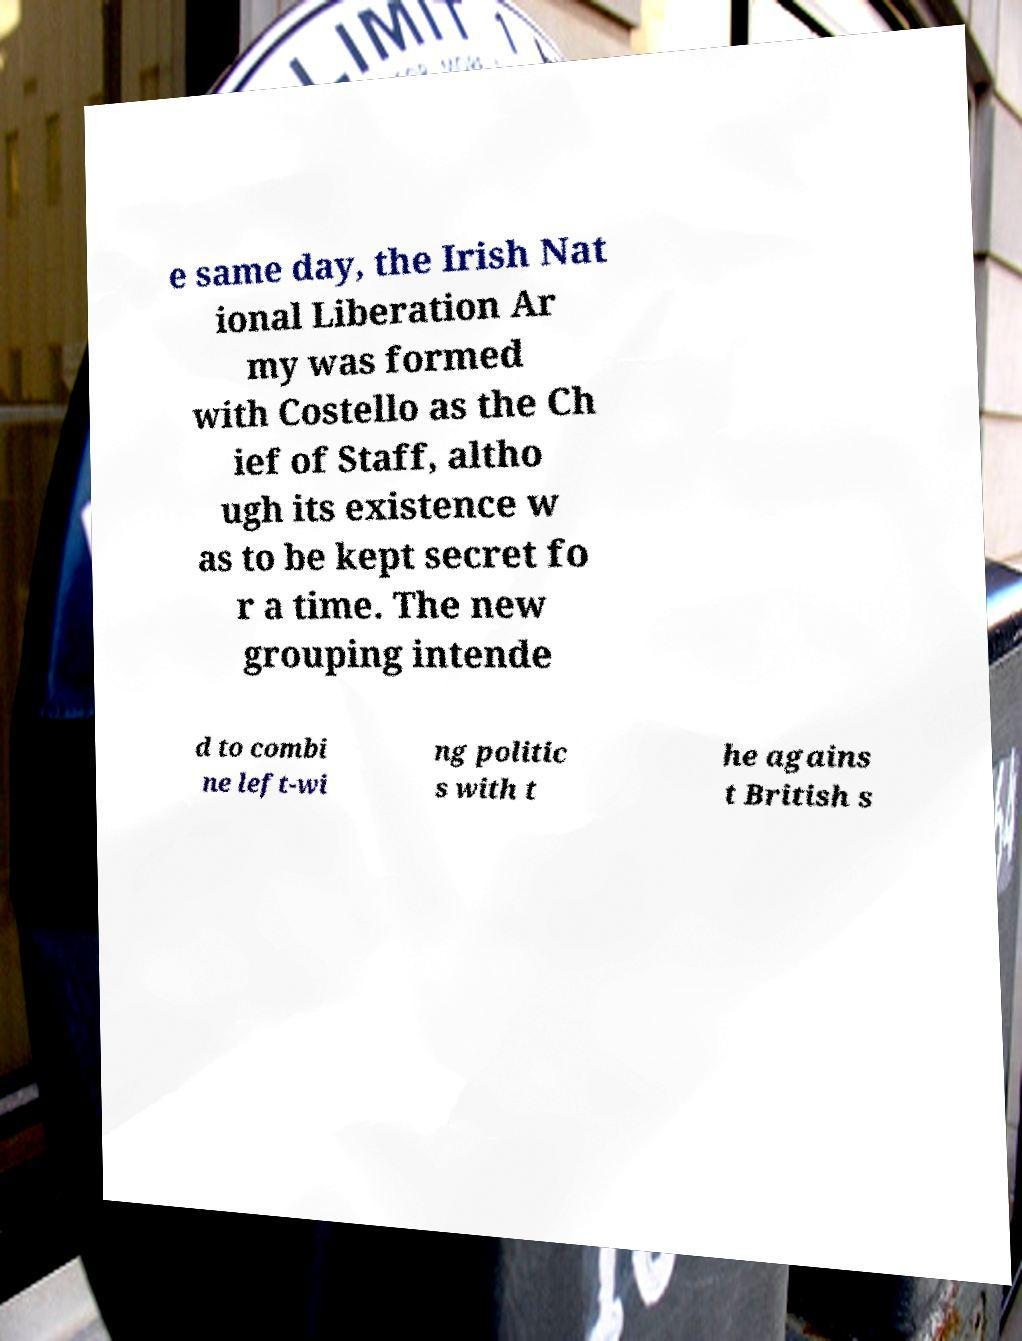Can you accurately transcribe the text from the provided image for me? e same day, the Irish Nat ional Liberation Ar my was formed with Costello as the Ch ief of Staff, altho ugh its existence w as to be kept secret fo r a time. The new grouping intende d to combi ne left-wi ng politic s with t he agains t British s 